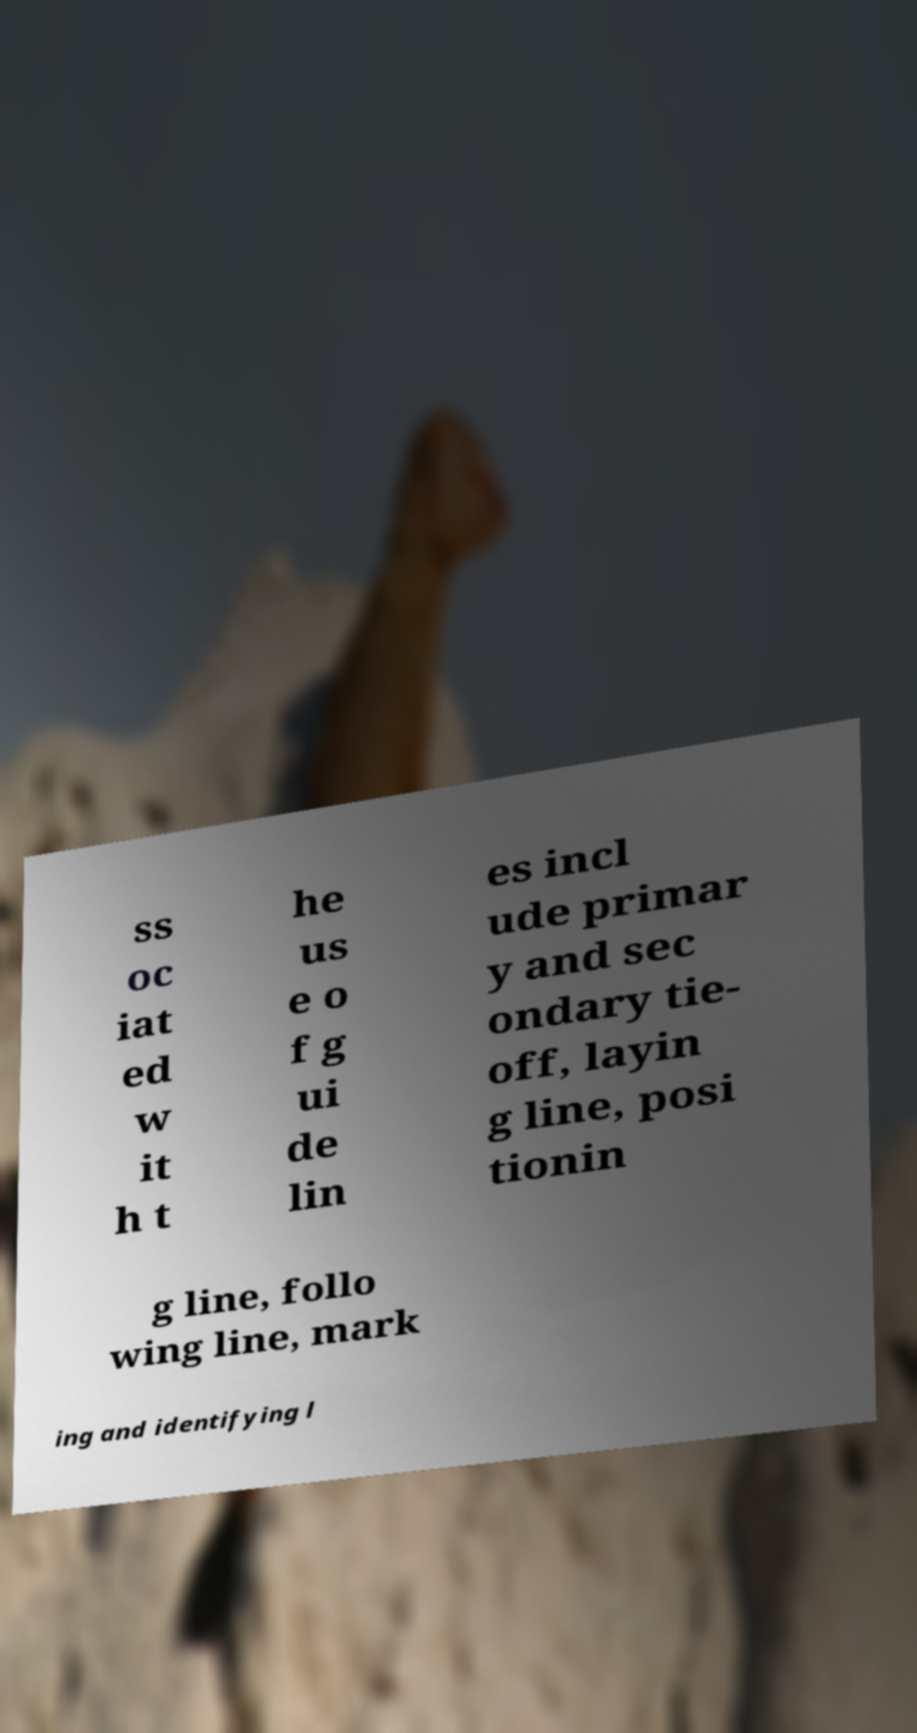Can you accurately transcribe the text from the provided image for me? ss oc iat ed w it h t he us e o f g ui de lin es incl ude primar y and sec ondary tie- off, layin g line, posi tionin g line, follo wing line, mark ing and identifying l 